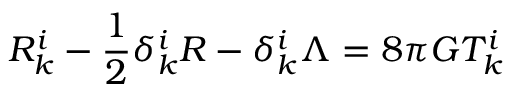<formula> <loc_0><loc_0><loc_500><loc_500>R _ { k } ^ { i } - \frac { 1 } { 2 } \delta _ { k } ^ { i } R - \delta _ { k } ^ { i } \Lambda = 8 \pi G T _ { k } ^ { i }</formula> 